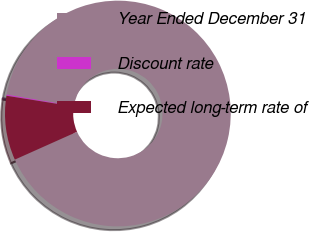Convert chart to OTSL. <chart><loc_0><loc_0><loc_500><loc_500><pie_chart><fcel>Year Ended December 31<fcel>Discount rate<fcel>Expected long-term rate of<nl><fcel>90.62%<fcel>0.17%<fcel>9.21%<nl></chart> 